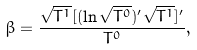Convert formula to latex. <formula><loc_0><loc_0><loc_500><loc_500>\beta = \frac { { \sqrt { T ^ { 1 } } [ ( \ln { \sqrt { T ^ { 0 } } } ) ^ { \prime } \sqrt { T ^ { 1 } } } ] ^ { \prime } } { T ^ { 0 } } ,</formula> 